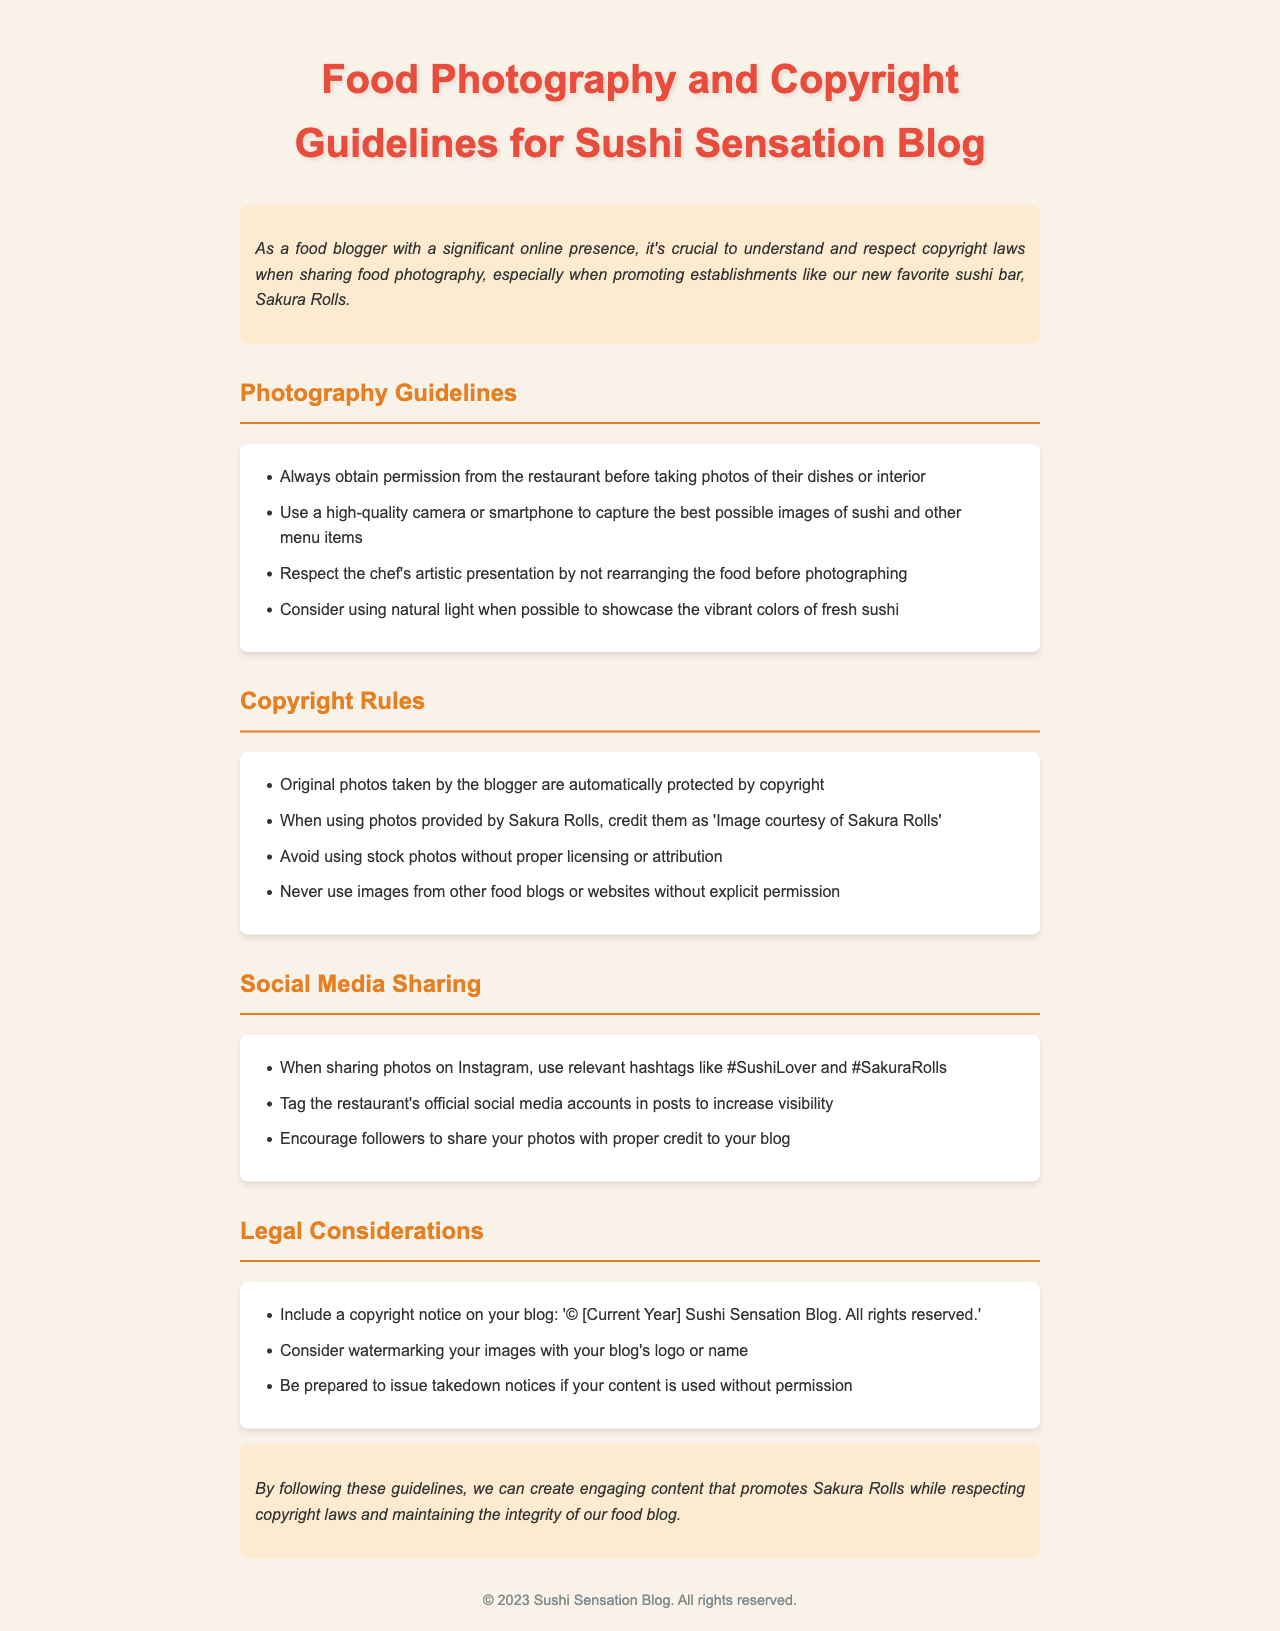what is the title of the document? The title is the main heading of the document, which indicates the subject matter.
Answer: Food Photography and Copyright Guidelines for Sushi Sensation Blog who should you credit when using photos provided by the restaurant? This refers to the requirement set within the copyright rules regarding photo attribution.
Answer: Image courtesy of Sakura Rolls what year should be included in the copyright notice? This year should reflect the current year that the guidelines are published and applicable.
Answer: 2023 what is recommended to showcase the colors of sushi? This suggestion is related to the photography guidelines aimed at improving image quality.
Answer: natural light how should you handle images from other food blogs? This instruction emphasizes the importance of respecting copyright laws in content use.
Answer: explicit permission what should you do if your content is used without permission? This question pertains to the legal aspects outlined in the document regarding content protection.
Answer: issue takedown notices 